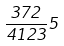<formula> <loc_0><loc_0><loc_500><loc_500>\frac { 3 7 2 } { 4 1 2 3 } 5</formula> 